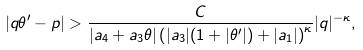<formula> <loc_0><loc_0><loc_500><loc_500>| q \theta ^ { \prime } - p | > \frac { C } { | a _ { 4 } + a _ { 3 } \theta | \left ( | a _ { 3 } | ( 1 + | \theta ^ { \prime } | ) + | a _ { 1 } | \right ) ^ { \kappa } } | q | ^ { - \kappa } ,</formula> 